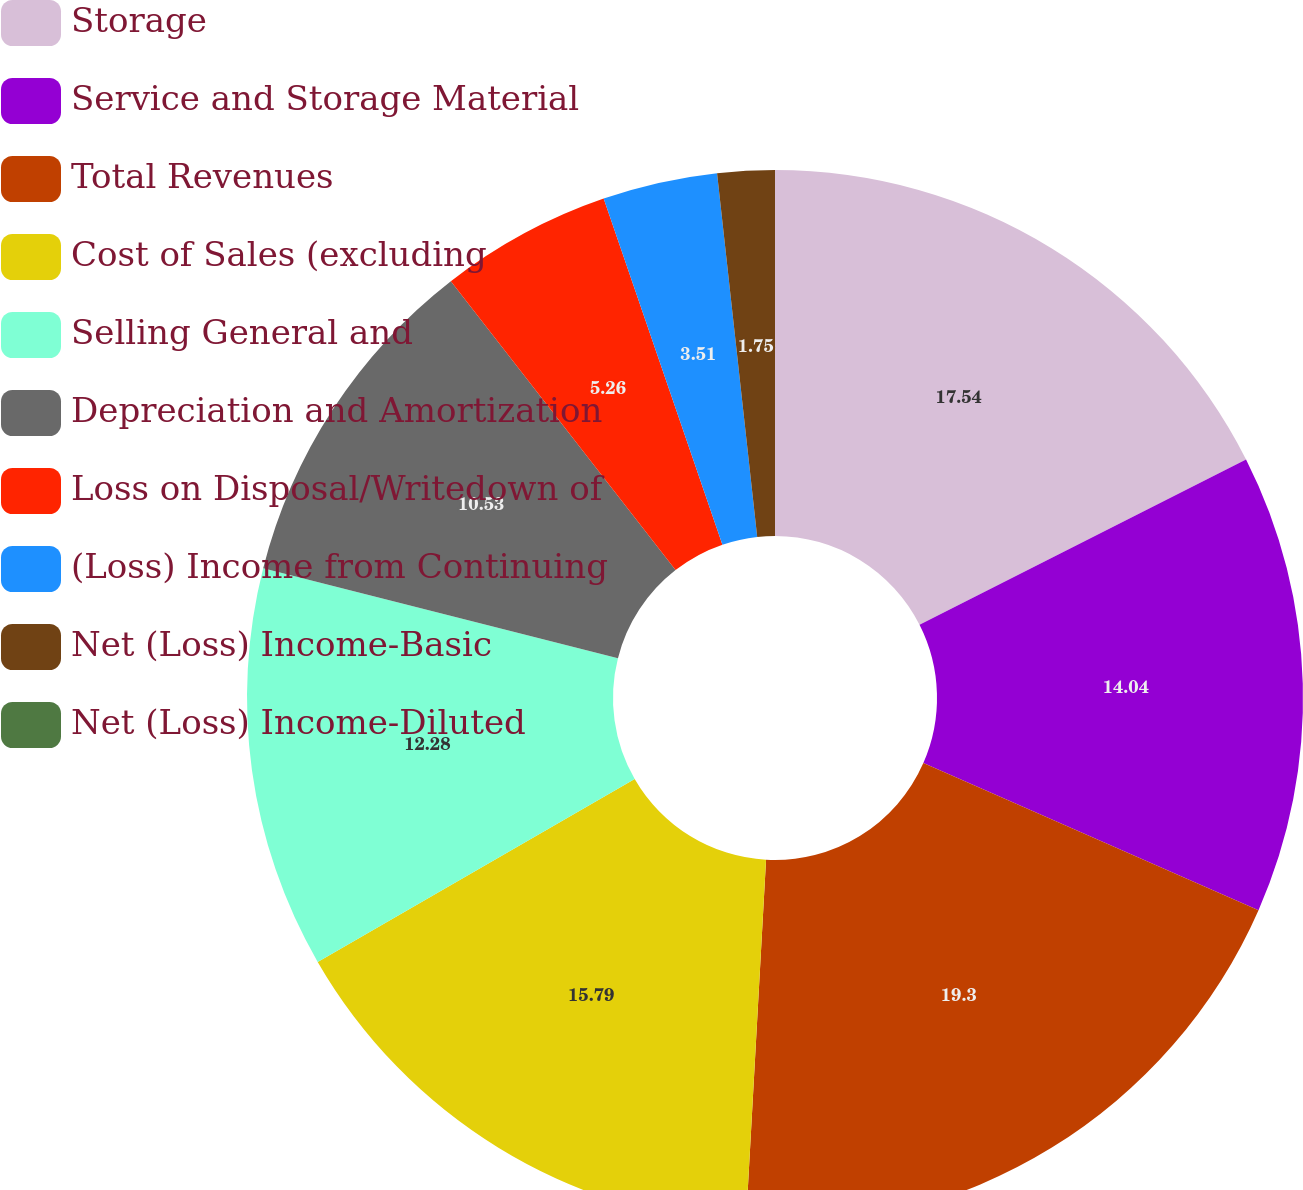Convert chart. <chart><loc_0><loc_0><loc_500><loc_500><pie_chart><fcel>Storage<fcel>Service and Storage Material<fcel>Total Revenues<fcel>Cost of Sales (excluding<fcel>Selling General and<fcel>Depreciation and Amortization<fcel>Loss on Disposal/Writedown of<fcel>(Loss) Income from Continuing<fcel>Net (Loss) Income-Basic<fcel>Net (Loss) Income-Diluted<nl><fcel>17.54%<fcel>14.04%<fcel>19.3%<fcel>15.79%<fcel>12.28%<fcel>10.53%<fcel>5.26%<fcel>3.51%<fcel>1.75%<fcel>0.0%<nl></chart> 